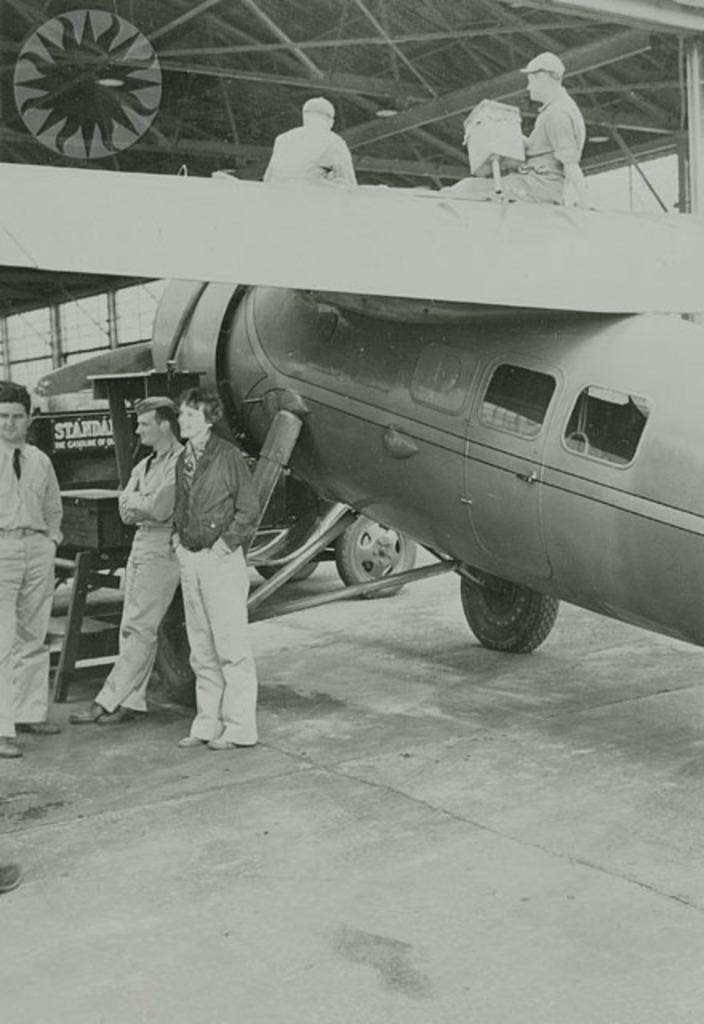Could you give a brief overview of what you see in this image? This image consists of many people. And there is a jet plane. At the bottom, there is a road. It looks like a black and white image. 